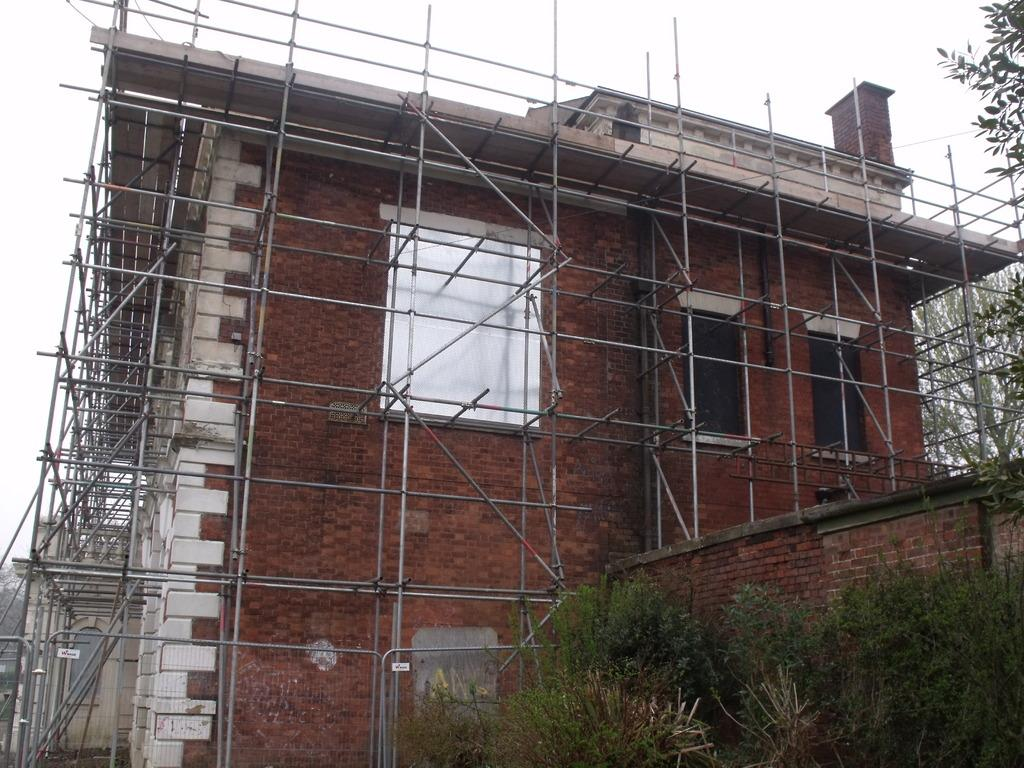What can be seen in the front of the image? There are trees in the front of the image. What is happening in the background of the image? There is a building under construction in the background of the image. Are there any trees visible in the background as well? Yes, there are trees in the background of the image. What type of clock is hanging from the tree in the image? There is no clock present in the image; it features trees in the front and a building under construction in the background. What thoughts are the trees having in the image? Trees do not have thoughts, as they are inanimate objects. 